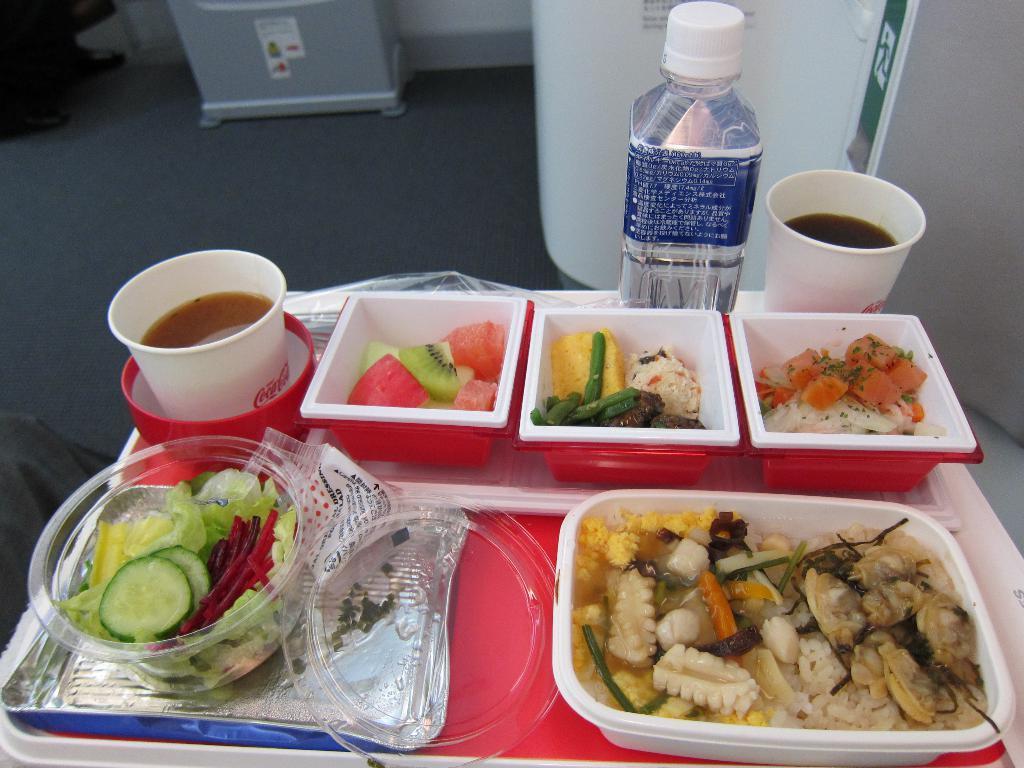Can you describe this image briefly? This picture shows a food items were on the table along with some cup with a drink and a water bottle. In the background, there is a floor here. 